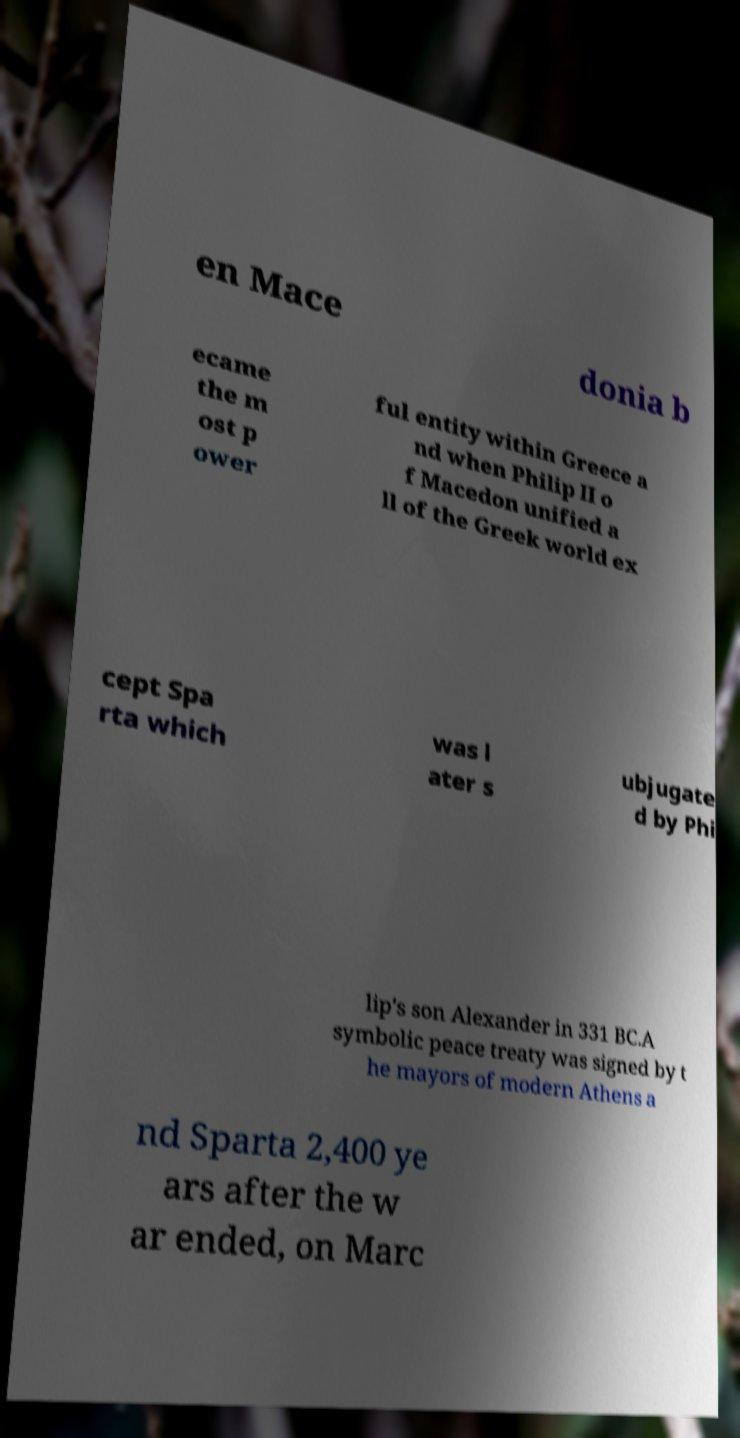Please read and relay the text visible in this image. What does it say? en Mace donia b ecame the m ost p ower ful entity within Greece a nd when Philip II o f Macedon unified a ll of the Greek world ex cept Spa rta which was l ater s ubjugate d by Phi lip's son Alexander in 331 BC.A symbolic peace treaty was signed by t he mayors of modern Athens a nd Sparta 2,400 ye ars after the w ar ended, on Marc 